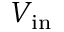<formula> <loc_0><loc_0><loc_500><loc_500>V _ { i n }</formula> 